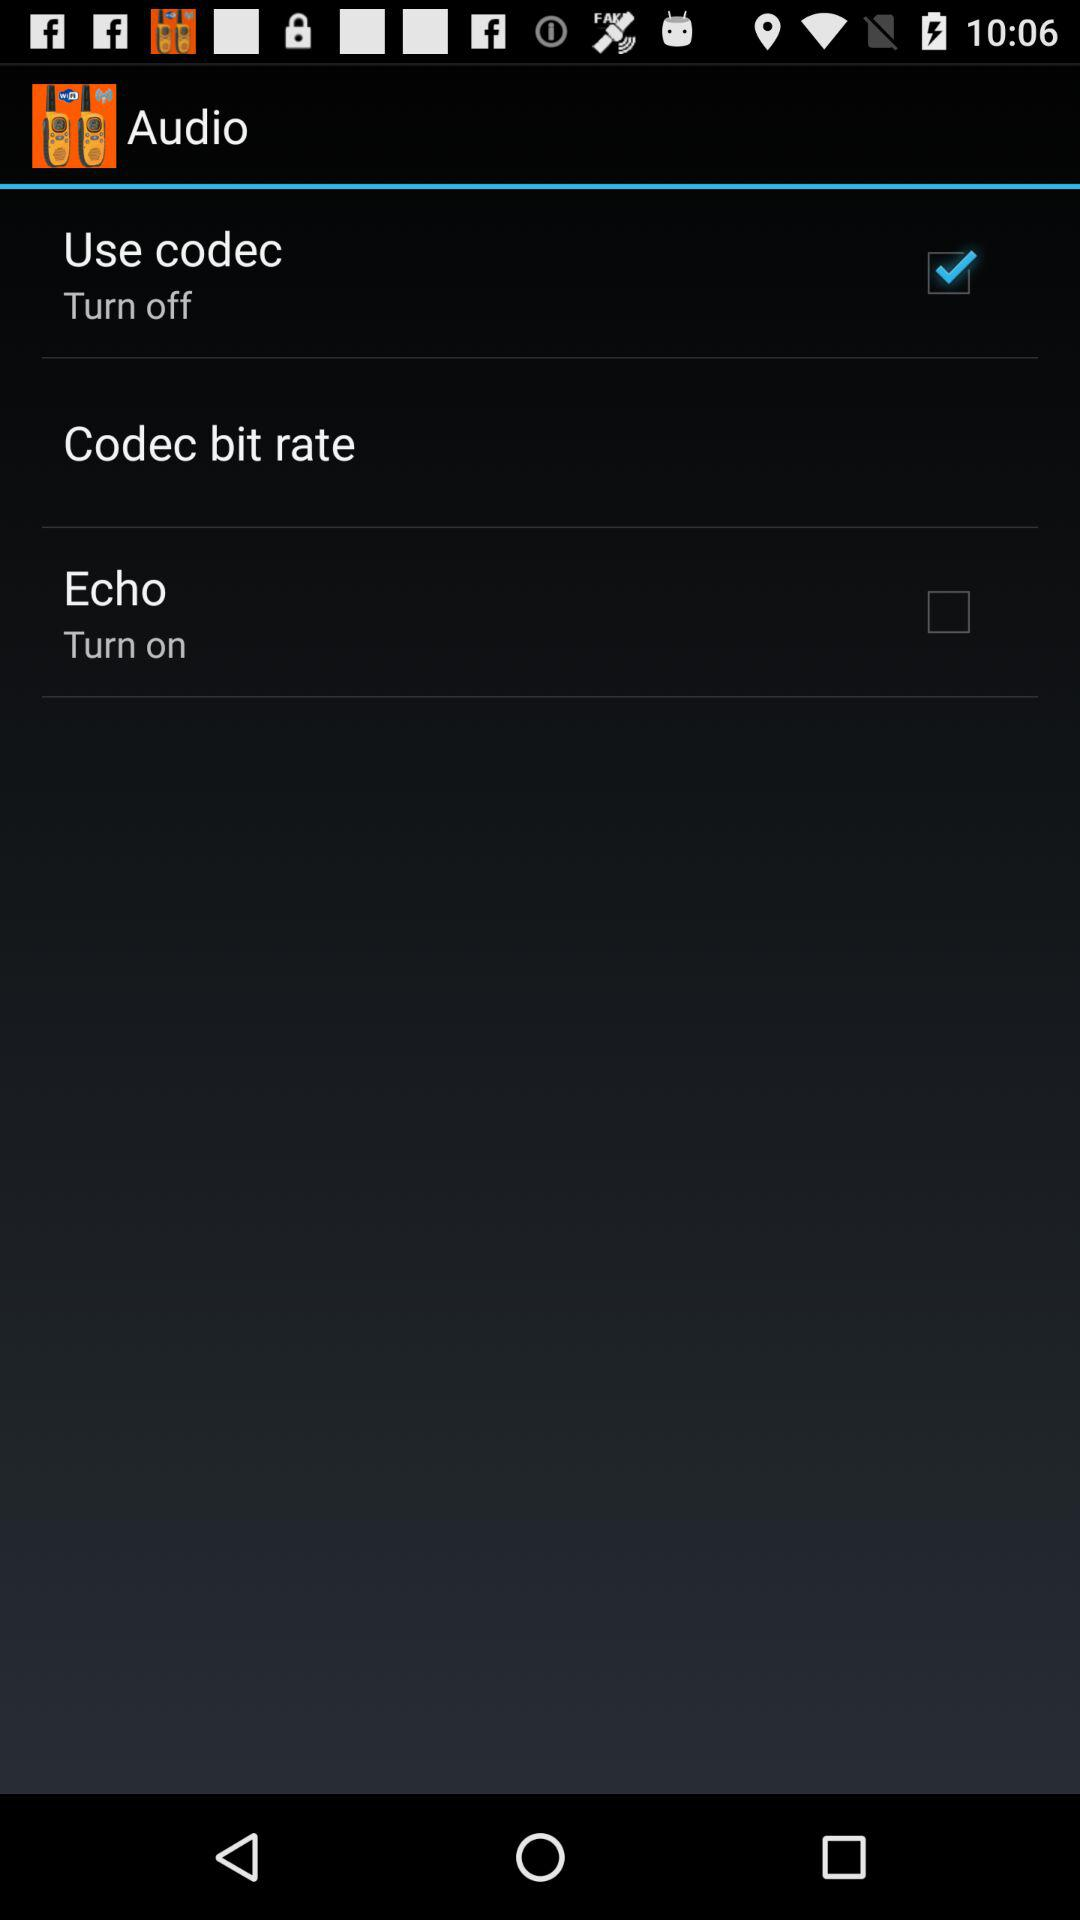How many items are there with both text and a checkbox?
Answer the question using a single word or phrase. 2 